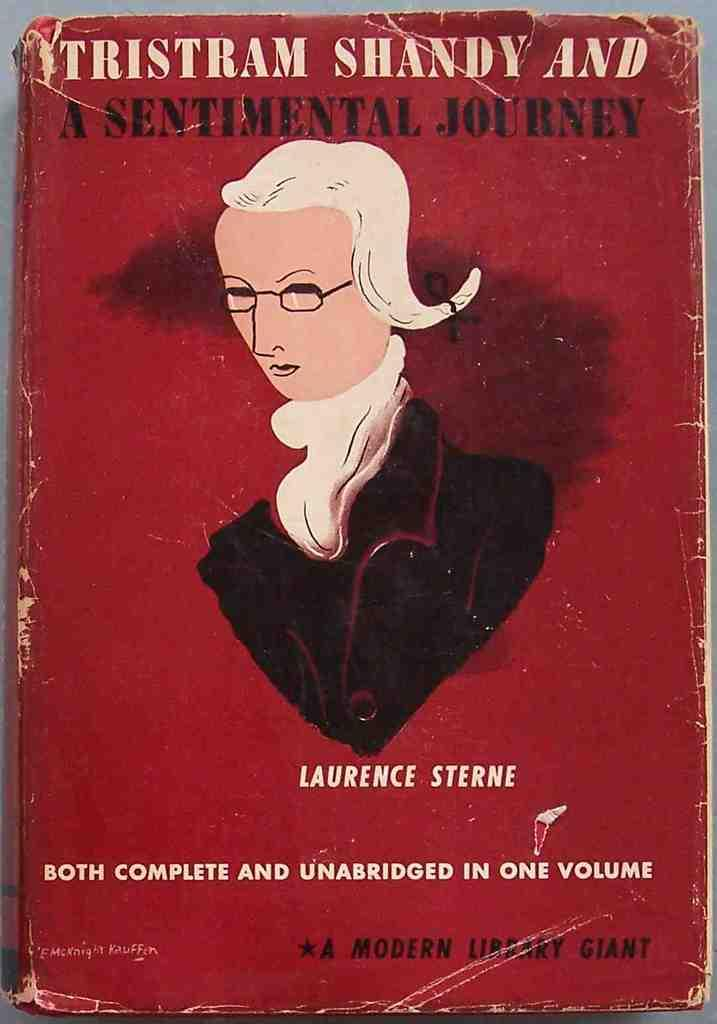What is the main subject of the image? The main subject of the image is the cover page of a book. What can be found on the cover page? There are texts and an image on the cover page. Where is the playground located in the image? There is no playground present in the image; it features the cover page of a book. What type of plough is being used by the person in the image? There is no person or plough present in the image; it features the cover page of a book. 